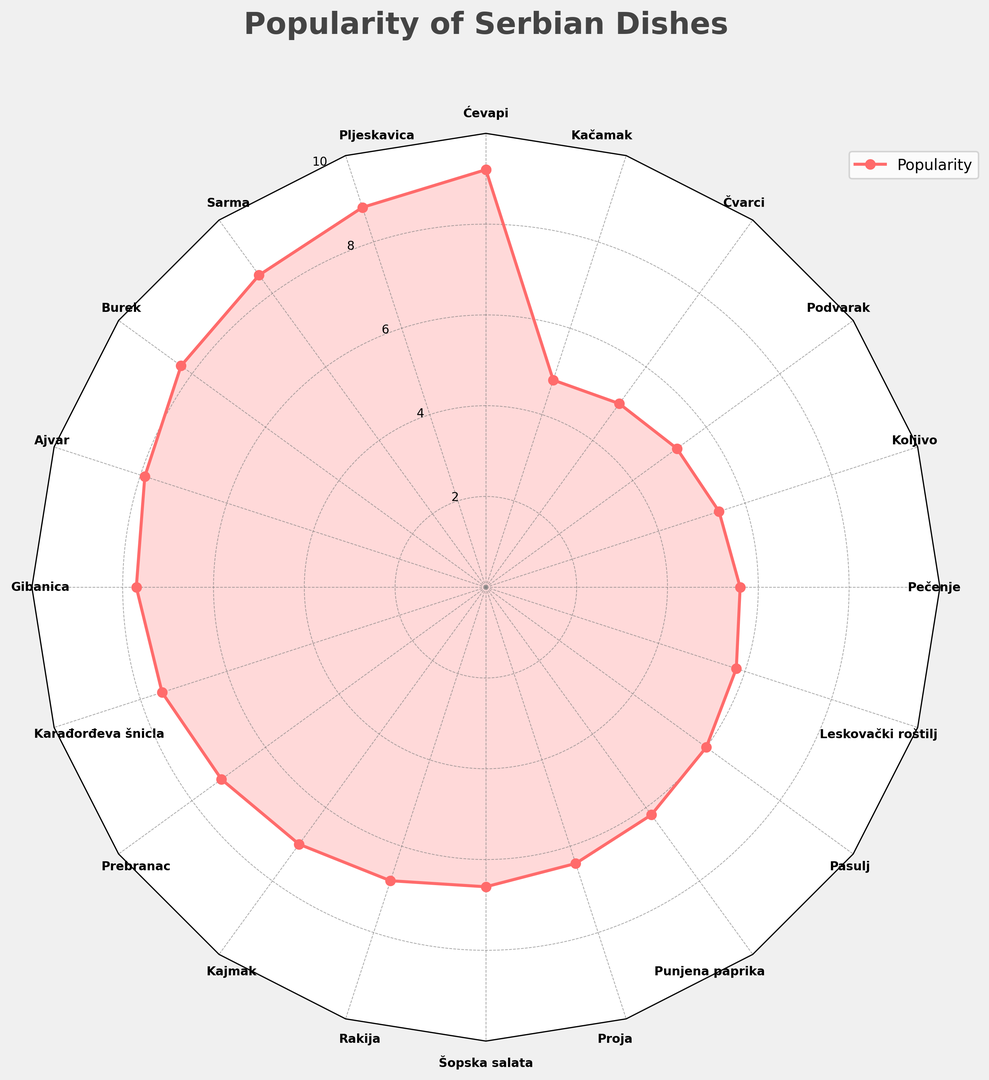What is the most popular dish? By looking at the plot, the dish with the highest value on the radar chart is the most popular. The highest value is 9.2 for Ćevapi.
Answer: Ćevapi Which dishes have a popularity score below 6.0? By checking the radar chart, the dishes with popularity values less than 6.0 are Kačamak, Čvarci, Podvarak, Pečenje, Leskovački roštilj, and Pasulj.
Answer: Kačamak, Čvarci, Podvarak, Pečenje, Leskovački roštilj, Pasulj What is the average popularity score of the top 5 dishes? The top 5 dishes are Ćevapi (9.2), Pljeskavica (8.8), Sarma (8.5), Burek (8.3), and Ajvar (7.9). Calculating the average: (9.2 + 8.8 + 8.5 + 8.3 + 7.9) / 5 = 42.7 / 5 = 8.54
Answer: 8.54 How does the popularity of Šopska salata compare to Gibanica? Looking at the radar chart, Šopska salata has a value of 6.6, and Gibanica has a value of 7.7. Thus, Gibanica is more popular than Šopska salata.
Answer: Gibanica is more popular What is the combined popularity score of Prebranac, Kajmak, and Rakija? Add the popularity values of Prebranac (7.2), Kajmak (7.0), and Rakija (6.8): 7.2 + 7.0 + 6.8 = 21.0
Answer: 21.0 Which dish is directly opposite Sarma on the radar chart? By looking at the angular position directly opposite to Sarma, which is approximately at π, the dish at 0 (2π) radians i.e., Prebranac, is its opposite.
Answer: Prebranac Which dish has the lowest popularity score? By checking the radar chart, the dish with the lowest value is Kačamak, with a score of 4.8.
Answer: Kačamak Compare the popularity of Karađorđeva šnicla and Prebranac. Which one is more preferred? Karađorđeva šnicla has a popularity score of 7.5, while Prebranac has a score of 7.2. Thus, Karađorđeva šnicla is more preferred.
Answer: Karađorđeva šnicla 